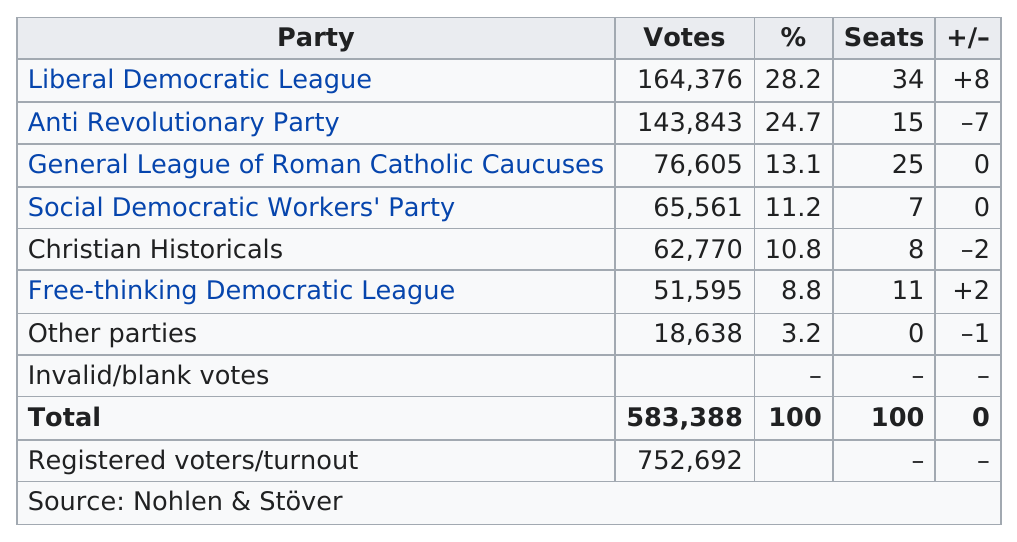List a handful of essential elements in this visual. The number of invalid or blank votes that were counted was 0. The Liberal Democratic League won more votes than the Free-Thinking Democratic League by 112,781 votes. After the election, the Liberal Democratic League won 34 seats. The Liberal Democratic League, Anti Revolutionary Party, and General League of Roman Catholic Caucuses are the top three parties in the given context. 